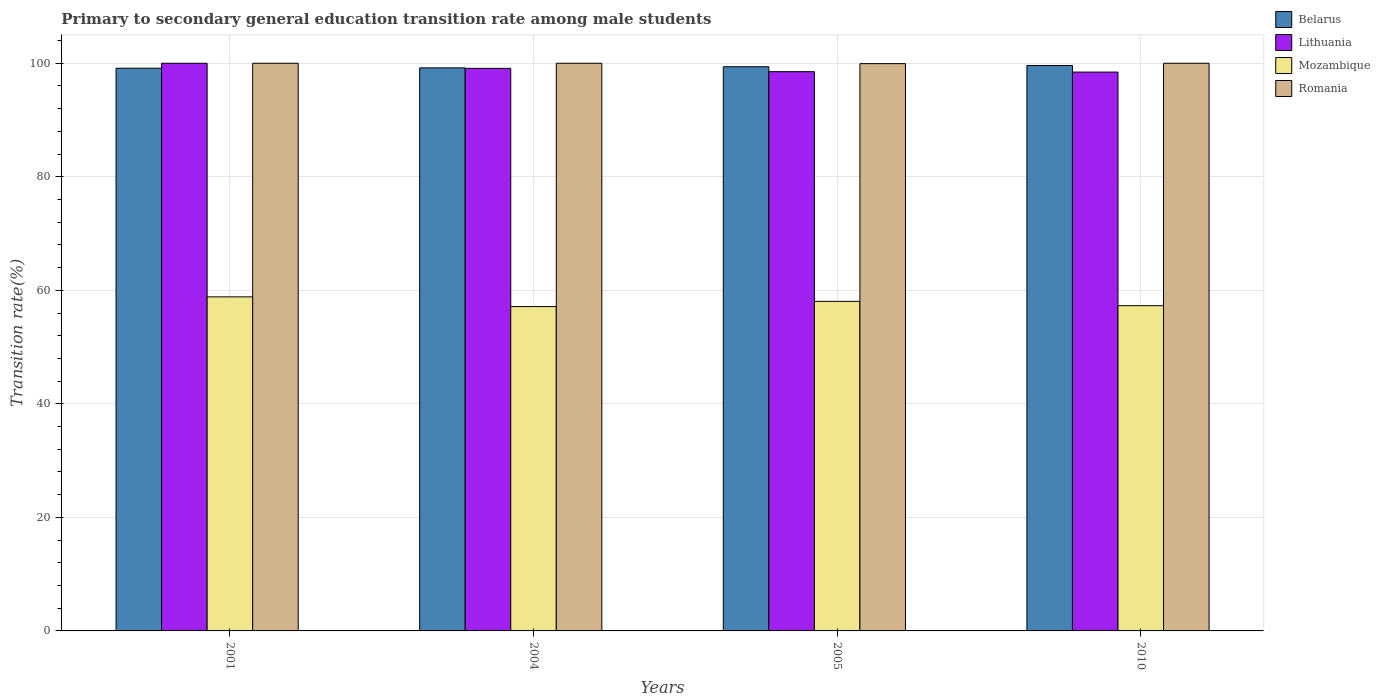How many different coloured bars are there?
Your answer should be compact. 4. How many groups of bars are there?
Make the answer very short. 4. Are the number of bars on each tick of the X-axis equal?
Give a very brief answer. Yes. How many bars are there on the 2nd tick from the right?
Provide a succinct answer. 4. In how many cases, is the number of bars for a given year not equal to the number of legend labels?
Offer a very short reply. 0. What is the transition rate in Belarus in 2001?
Provide a short and direct response. 99.13. Across all years, what is the minimum transition rate in Romania?
Offer a terse response. 99.93. In which year was the transition rate in Mozambique maximum?
Provide a short and direct response. 2001. What is the total transition rate in Lithuania in the graph?
Make the answer very short. 396.07. What is the difference between the transition rate in Lithuania in 2004 and that in 2005?
Make the answer very short. 0.58. What is the difference between the transition rate in Belarus in 2005 and the transition rate in Mozambique in 2004?
Make the answer very short. 42.25. What is the average transition rate in Mozambique per year?
Keep it short and to the point. 57.83. In the year 2004, what is the difference between the transition rate in Romania and transition rate in Lithuania?
Give a very brief answer. 0.9. In how many years, is the transition rate in Mozambique greater than 92 %?
Ensure brevity in your answer.  0. What is the ratio of the transition rate in Mozambique in 2005 to that in 2010?
Give a very brief answer. 1.01. Is the transition rate in Mozambique in 2001 less than that in 2004?
Your answer should be compact. No. What is the difference between the highest and the second highest transition rate in Lithuania?
Your answer should be compact. 0.9. What is the difference between the highest and the lowest transition rate in Belarus?
Keep it short and to the point. 0.48. Is it the case that in every year, the sum of the transition rate in Mozambique and transition rate in Belarus is greater than the sum of transition rate in Lithuania and transition rate in Romania?
Provide a succinct answer. No. What does the 3rd bar from the left in 2004 represents?
Your answer should be very brief. Mozambique. What does the 4th bar from the right in 2010 represents?
Offer a terse response. Belarus. How many bars are there?
Provide a succinct answer. 16. How many years are there in the graph?
Your answer should be very brief. 4. Are the values on the major ticks of Y-axis written in scientific E-notation?
Offer a terse response. No. Does the graph contain any zero values?
Keep it short and to the point. No. Where does the legend appear in the graph?
Provide a succinct answer. Top right. How many legend labels are there?
Offer a very short reply. 4. What is the title of the graph?
Make the answer very short. Primary to secondary general education transition rate among male students. What is the label or title of the Y-axis?
Your answer should be very brief. Transition rate(%). What is the Transition rate(%) in Belarus in 2001?
Keep it short and to the point. 99.13. What is the Transition rate(%) of Mozambique in 2001?
Ensure brevity in your answer.  58.85. What is the Transition rate(%) of Belarus in 2004?
Provide a short and direct response. 99.19. What is the Transition rate(%) of Lithuania in 2004?
Your response must be concise. 99.1. What is the Transition rate(%) of Mozambique in 2004?
Keep it short and to the point. 57.14. What is the Transition rate(%) of Romania in 2004?
Give a very brief answer. 100. What is the Transition rate(%) of Belarus in 2005?
Ensure brevity in your answer.  99.39. What is the Transition rate(%) in Lithuania in 2005?
Ensure brevity in your answer.  98.52. What is the Transition rate(%) of Mozambique in 2005?
Make the answer very short. 58.06. What is the Transition rate(%) of Romania in 2005?
Make the answer very short. 99.93. What is the Transition rate(%) of Belarus in 2010?
Provide a short and direct response. 99.61. What is the Transition rate(%) of Lithuania in 2010?
Make the answer very short. 98.44. What is the Transition rate(%) in Mozambique in 2010?
Provide a short and direct response. 57.3. Across all years, what is the maximum Transition rate(%) of Belarus?
Offer a terse response. 99.61. Across all years, what is the maximum Transition rate(%) in Lithuania?
Offer a terse response. 100. Across all years, what is the maximum Transition rate(%) in Mozambique?
Provide a succinct answer. 58.85. Across all years, what is the maximum Transition rate(%) of Romania?
Make the answer very short. 100. Across all years, what is the minimum Transition rate(%) in Belarus?
Offer a terse response. 99.13. Across all years, what is the minimum Transition rate(%) of Lithuania?
Your answer should be very brief. 98.44. Across all years, what is the minimum Transition rate(%) of Mozambique?
Your answer should be very brief. 57.14. Across all years, what is the minimum Transition rate(%) of Romania?
Offer a very short reply. 99.93. What is the total Transition rate(%) of Belarus in the graph?
Provide a short and direct response. 397.31. What is the total Transition rate(%) in Lithuania in the graph?
Offer a terse response. 396.07. What is the total Transition rate(%) in Mozambique in the graph?
Ensure brevity in your answer.  231.34. What is the total Transition rate(%) of Romania in the graph?
Provide a succinct answer. 399.93. What is the difference between the Transition rate(%) of Belarus in 2001 and that in 2004?
Keep it short and to the point. -0.06. What is the difference between the Transition rate(%) of Lithuania in 2001 and that in 2004?
Ensure brevity in your answer.  0.9. What is the difference between the Transition rate(%) in Mozambique in 2001 and that in 2004?
Your answer should be compact. 1.71. What is the difference between the Transition rate(%) in Romania in 2001 and that in 2004?
Your answer should be compact. 0. What is the difference between the Transition rate(%) of Belarus in 2001 and that in 2005?
Keep it short and to the point. -0.26. What is the difference between the Transition rate(%) of Lithuania in 2001 and that in 2005?
Provide a succinct answer. 1.48. What is the difference between the Transition rate(%) in Mozambique in 2001 and that in 2005?
Your response must be concise. 0.79. What is the difference between the Transition rate(%) of Romania in 2001 and that in 2005?
Your answer should be compact. 0.07. What is the difference between the Transition rate(%) of Belarus in 2001 and that in 2010?
Ensure brevity in your answer.  -0.48. What is the difference between the Transition rate(%) in Lithuania in 2001 and that in 2010?
Provide a short and direct response. 1.56. What is the difference between the Transition rate(%) in Mozambique in 2001 and that in 2010?
Ensure brevity in your answer.  1.55. What is the difference between the Transition rate(%) of Romania in 2001 and that in 2010?
Your answer should be compact. 0. What is the difference between the Transition rate(%) of Belarus in 2004 and that in 2005?
Give a very brief answer. -0.2. What is the difference between the Transition rate(%) of Lithuania in 2004 and that in 2005?
Keep it short and to the point. 0.58. What is the difference between the Transition rate(%) in Mozambique in 2004 and that in 2005?
Your answer should be compact. -0.92. What is the difference between the Transition rate(%) of Romania in 2004 and that in 2005?
Provide a succinct answer. 0.07. What is the difference between the Transition rate(%) of Belarus in 2004 and that in 2010?
Your response must be concise. -0.42. What is the difference between the Transition rate(%) of Lithuania in 2004 and that in 2010?
Offer a very short reply. 0.66. What is the difference between the Transition rate(%) in Mozambique in 2004 and that in 2010?
Make the answer very short. -0.16. What is the difference between the Transition rate(%) in Belarus in 2005 and that in 2010?
Provide a short and direct response. -0.22. What is the difference between the Transition rate(%) of Lithuania in 2005 and that in 2010?
Provide a short and direct response. 0.08. What is the difference between the Transition rate(%) of Mozambique in 2005 and that in 2010?
Your answer should be compact. 0.76. What is the difference between the Transition rate(%) in Romania in 2005 and that in 2010?
Ensure brevity in your answer.  -0.07. What is the difference between the Transition rate(%) in Belarus in 2001 and the Transition rate(%) in Lithuania in 2004?
Provide a short and direct response. 0.02. What is the difference between the Transition rate(%) of Belarus in 2001 and the Transition rate(%) of Mozambique in 2004?
Your answer should be very brief. 41.99. What is the difference between the Transition rate(%) of Belarus in 2001 and the Transition rate(%) of Romania in 2004?
Provide a succinct answer. -0.87. What is the difference between the Transition rate(%) of Lithuania in 2001 and the Transition rate(%) of Mozambique in 2004?
Your answer should be very brief. 42.86. What is the difference between the Transition rate(%) of Mozambique in 2001 and the Transition rate(%) of Romania in 2004?
Make the answer very short. -41.15. What is the difference between the Transition rate(%) of Belarus in 2001 and the Transition rate(%) of Lithuania in 2005?
Keep it short and to the point. 0.61. What is the difference between the Transition rate(%) in Belarus in 2001 and the Transition rate(%) in Mozambique in 2005?
Make the answer very short. 41.07. What is the difference between the Transition rate(%) in Belarus in 2001 and the Transition rate(%) in Romania in 2005?
Provide a succinct answer. -0.81. What is the difference between the Transition rate(%) in Lithuania in 2001 and the Transition rate(%) in Mozambique in 2005?
Provide a succinct answer. 41.94. What is the difference between the Transition rate(%) in Lithuania in 2001 and the Transition rate(%) in Romania in 2005?
Offer a very short reply. 0.07. What is the difference between the Transition rate(%) of Mozambique in 2001 and the Transition rate(%) of Romania in 2005?
Your response must be concise. -41.09. What is the difference between the Transition rate(%) in Belarus in 2001 and the Transition rate(%) in Lithuania in 2010?
Your answer should be compact. 0.68. What is the difference between the Transition rate(%) in Belarus in 2001 and the Transition rate(%) in Mozambique in 2010?
Your response must be concise. 41.83. What is the difference between the Transition rate(%) in Belarus in 2001 and the Transition rate(%) in Romania in 2010?
Your response must be concise. -0.87. What is the difference between the Transition rate(%) in Lithuania in 2001 and the Transition rate(%) in Mozambique in 2010?
Offer a very short reply. 42.7. What is the difference between the Transition rate(%) of Mozambique in 2001 and the Transition rate(%) of Romania in 2010?
Your answer should be compact. -41.15. What is the difference between the Transition rate(%) of Belarus in 2004 and the Transition rate(%) of Lithuania in 2005?
Your answer should be compact. 0.67. What is the difference between the Transition rate(%) of Belarus in 2004 and the Transition rate(%) of Mozambique in 2005?
Your answer should be very brief. 41.13. What is the difference between the Transition rate(%) of Belarus in 2004 and the Transition rate(%) of Romania in 2005?
Make the answer very short. -0.75. What is the difference between the Transition rate(%) in Lithuania in 2004 and the Transition rate(%) in Mozambique in 2005?
Make the answer very short. 41.05. What is the difference between the Transition rate(%) in Lithuania in 2004 and the Transition rate(%) in Romania in 2005?
Give a very brief answer. -0.83. What is the difference between the Transition rate(%) in Mozambique in 2004 and the Transition rate(%) in Romania in 2005?
Offer a terse response. -42.8. What is the difference between the Transition rate(%) of Belarus in 2004 and the Transition rate(%) of Lithuania in 2010?
Provide a succinct answer. 0.74. What is the difference between the Transition rate(%) of Belarus in 2004 and the Transition rate(%) of Mozambique in 2010?
Your response must be concise. 41.89. What is the difference between the Transition rate(%) in Belarus in 2004 and the Transition rate(%) in Romania in 2010?
Make the answer very short. -0.81. What is the difference between the Transition rate(%) in Lithuania in 2004 and the Transition rate(%) in Mozambique in 2010?
Make the answer very short. 41.8. What is the difference between the Transition rate(%) of Lithuania in 2004 and the Transition rate(%) of Romania in 2010?
Provide a short and direct response. -0.9. What is the difference between the Transition rate(%) in Mozambique in 2004 and the Transition rate(%) in Romania in 2010?
Ensure brevity in your answer.  -42.86. What is the difference between the Transition rate(%) of Belarus in 2005 and the Transition rate(%) of Lithuania in 2010?
Offer a terse response. 0.95. What is the difference between the Transition rate(%) of Belarus in 2005 and the Transition rate(%) of Mozambique in 2010?
Your response must be concise. 42.09. What is the difference between the Transition rate(%) of Belarus in 2005 and the Transition rate(%) of Romania in 2010?
Your answer should be compact. -0.61. What is the difference between the Transition rate(%) in Lithuania in 2005 and the Transition rate(%) in Mozambique in 2010?
Provide a succinct answer. 41.22. What is the difference between the Transition rate(%) of Lithuania in 2005 and the Transition rate(%) of Romania in 2010?
Offer a very short reply. -1.48. What is the difference between the Transition rate(%) in Mozambique in 2005 and the Transition rate(%) in Romania in 2010?
Your answer should be very brief. -41.94. What is the average Transition rate(%) of Belarus per year?
Give a very brief answer. 99.33. What is the average Transition rate(%) in Lithuania per year?
Provide a succinct answer. 99.02. What is the average Transition rate(%) in Mozambique per year?
Your response must be concise. 57.83. What is the average Transition rate(%) of Romania per year?
Your answer should be very brief. 99.98. In the year 2001, what is the difference between the Transition rate(%) in Belarus and Transition rate(%) in Lithuania?
Ensure brevity in your answer.  -0.87. In the year 2001, what is the difference between the Transition rate(%) in Belarus and Transition rate(%) in Mozambique?
Ensure brevity in your answer.  40.28. In the year 2001, what is the difference between the Transition rate(%) in Belarus and Transition rate(%) in Romania?
Provide a succinct answer. -0.87. In the year 2001, what is the difference between the Transition rate(%) of Lithuania and Transition rate(%) of Mozambique?
Ensure brevity in your answer.  41.15. In the year 2001, what is the difference between the Transition rate(%) of Mozambique and Transition rate(%) of Romania?
Offer a very short reply. -41.15. In the year 2004, what is the difference between the Transition rate(%) of Belarus and Transition rate(%) of Lithuania?
Keep it short and to the point. 0.08. In the year 2004, what is the difference between the Transition rate(%) of Belarus and Transition rate(%) of Mozambique?
Make the answer very short. 42.05. In the year 2004, what is the difference between the Transition rate(%) of Belarus and Transition rate(%) of Romania?
Give a very brief answer. -0.81. In the year 2004, what is the difference between the Transition rate(%) in Lithuania and Transition rate(%) in Mozambique?
Give a very brief answer. 41.97. In the year 2004, what is the difference between the Transition rate(%) in Lithuania and Transition rate(%) in Romania?
Keep it short and to the point. -0.9. In the year 2004, what is the difference between the Transition rate(%) of Mozambique and Transition rate(%) of Romania?
Give a very brief answer. -42.86. In the year 2005, what is the difference between the Transition rate(%) of Belarus and Transition rate(%) of Lithuania?
Ensure brevity in your answer.  0.87. In the year 2005, what is the difference between the Transition rate(%) in Belarus and Transition rate(%) in Mozambique?
Your response must be concise. 41.33. In the year 2005, what is the difference between the Transition rate(%) of Belarus and Transition rate(%) of Romania?
Provide a succinct answer. -0.54. In the year 2005, what is the difference between the Transition rate(%) of Lithuania and Transition rate(%) of Mozambique?
Your answer should be compact. 40.46. In the year 2005, what is the difference between the Transition rate(%) of Lithuania and Transition rate(%) of Romania?
Offer a terse response. -1.41. In the year 2005, what is the difference between the Transition rate(%) in Mozambique and Transition rate(%) in Romania?
Ensure brevity in your answer.  -41.88. In the year 2010, what is the difference between the Transition rate(%) in Belarus and Transition rate(%) in Lithuania?
Your answer should be very brief. 1.16. In the year 2010, what is the difference between the Transition rate(%) in Belarus and Transition rate(%) in Mozambique?
Provide a short and direct response. 42.31. In the year 2010, what is the difference between the Transition rate(%) in Belarus and Transition rate(%) in Romania?
Keep it short and to the point. -0.39. In the year 2010, what is the difference between the Transition rate(%) of Lithuania and Transition rate(%) of Mozambique?
Offer a very short reply. 41.15. In the year 2010, what is the difference between the Transition rate(%) of Lithuania and Transition rate(%) of Romania?
Keep it short and to the point. -1.56. In the year 2010, what is the difference between the Transition rate(%) in Mozambique and Transition rate(%) in Romania?
Your answer should be compact. -42.7. What is the ratio of the Transition rate(%) of Belarus in 2001 to that in 2004?
Offer a terse response. 1. What is the ratio of the Transition rate(%) in Lithuania in 2001 to that in 2004?
Give a very brief answer. 1.01. What is the ratio of the Transition rate(%) of Mozambique in 2001 to that in 2004?
Provide a short and direct response. 1.03. What is the ratio of the Transition rate(%) of Belarus in 2001 to that in 2005?
Offer a terse response. 1. What is the ratio of the Transition rate(%) of Mozambique in 2001 to that in 2005?
Your answer should be very brief. 1.01. What is the ratio of the Transition rate(%) of Romania in 2001 to that in 2005?
Ensure brevity in your answer.  1. What is the ratio of the Transition rate(%) in Lithuania in 2001 to that in 2010?
Make the answer very short. 1.02. What is the ratio of the Transition rate(%) in Mozambique in 2001 to that in 2010?
Your answer should be very brief. 1.03. What is the ratio of the Transition rate(%) in Belarus in 2004 to that in 2005?
Offer a very short reply. 1. What is the ratio of the Transition rate(%) of Lithuania in 2004 to that in 2005?
Offer a very short reply. 1.01. What is the ratio of the Transition rate(%) in Mozambique in 2004 to that in 2005?
Keep it short and to the point. 0.98. What is the ratio of the Transition rate(%) in Mozambique in 2004 to that in 2010?
Keep it short and to the point. 1. What is the ratio of the Transition rate(%) in Belarus in 2005 to that in 2010?
Your answer should be compact. 1. What is the ratio of the Transition rate(%) in Lithuania in 2005 to that in 2010?
Make the answer very short. 1. What is the ratio of the Transition rate(%) in Mozambique in 2005 to that in 2010?
Your answer should be compact. 1.01. What is the difference between the highest and the second highest Transition rate(%) of Belarus?
Ensure brevity in your answer.  0.22. What is the difference between the highest and the second highest Transition rate(%) in Lithuania?
Offer a very short reply. 0.9. What is the difference between the highest and the second highest Transition rate(%) of Mozambique?
Ensure brevity in your answer.  0.79. What is the difference between the highest and the lowest Transition rate(%) in Belarus?
Your response must be concise. 0.48. What is the difference between the highest and the lowest Transition rate(%) of Lithuania?
Ensure brevity in your answer.  1.56. What is the difference between the highest and the lowest Transition rate(%) in Mozambique?
Provide a short and direct response. 1.71. What is the difference between the highest and the lowest Transition rate(%) of Romania?
Ensure brevity in your answer.  0.07. 